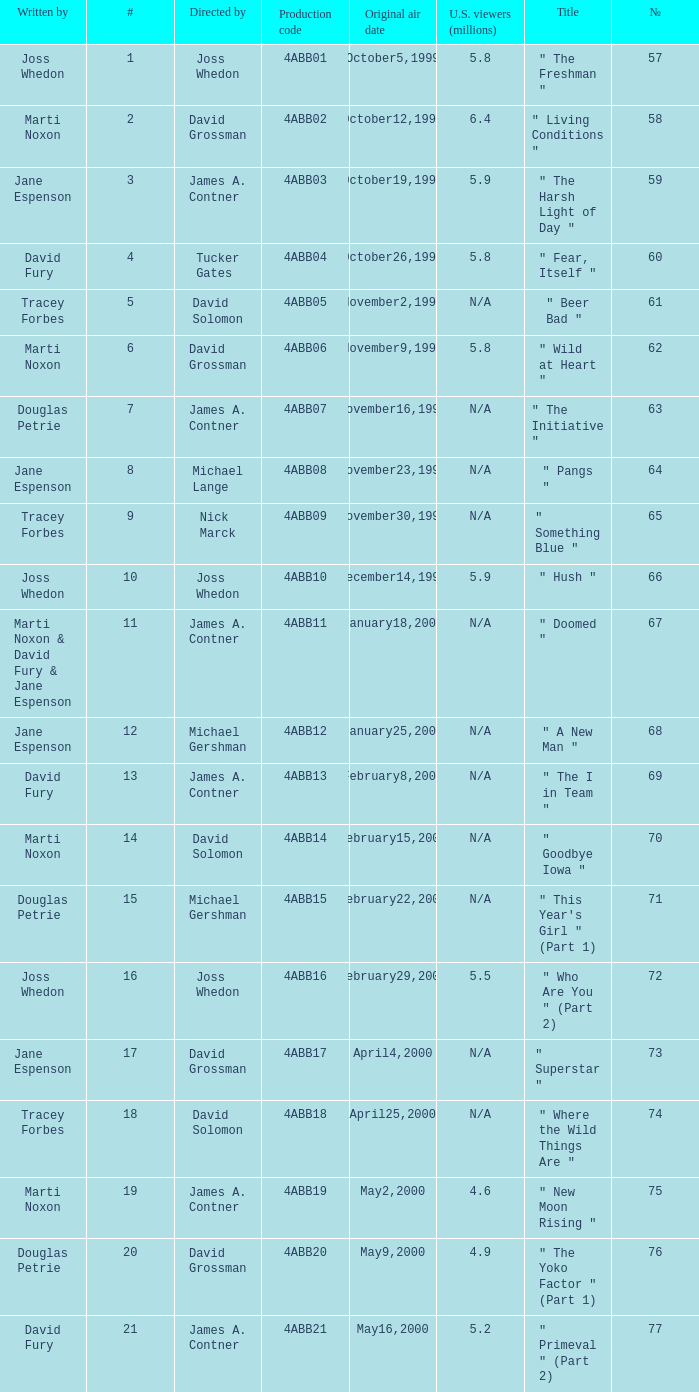What is the season 4 # for the production code of 4abb07? 7.0. 